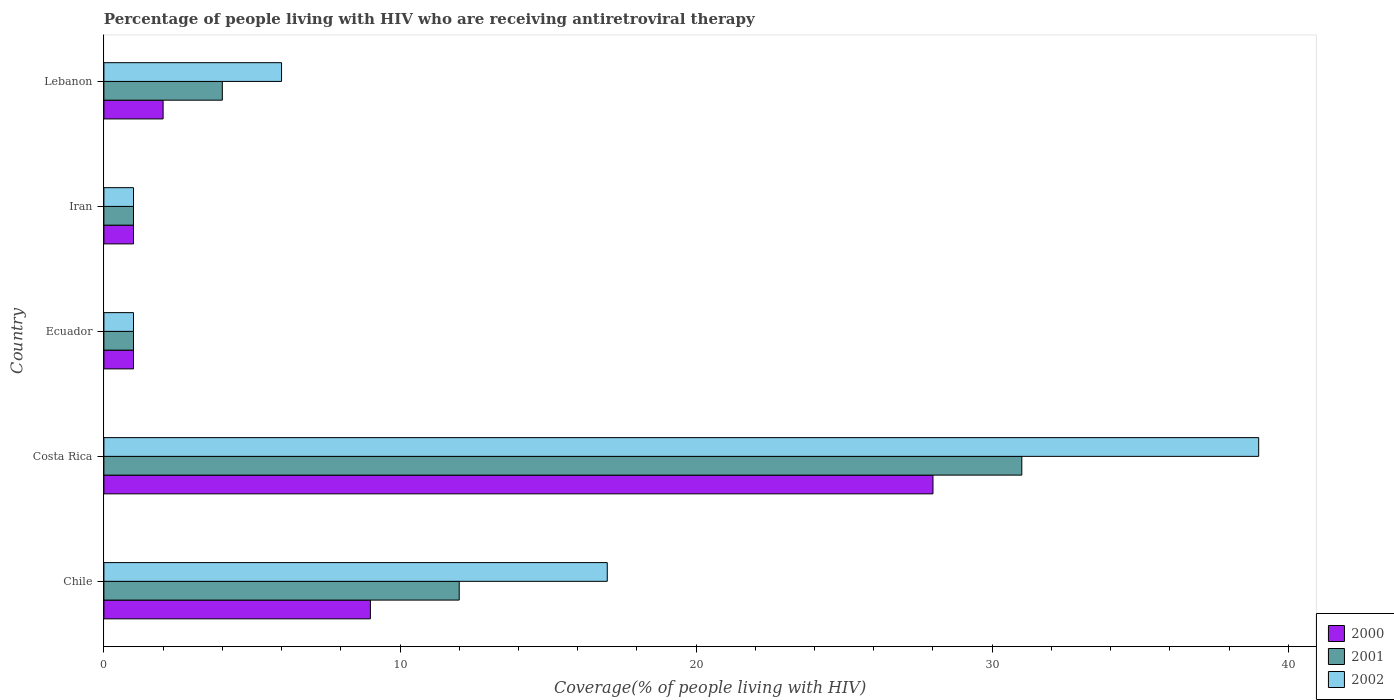How many different coloured bars are there?
Keep it short and to the point. 3. How many groups of bars are there?
Make the answer very short. 5. Are the number of bars per tick equal to the number of legend labels?
Make the answer very short. Yes. How many bars are there on the 1st tick from the bottom?
Ensure brevity in your answer.  3. What is the label of the 3rd group of bars from the top?
Your response must be concise. Ecuador. What is the percentage of the HIV infected people who are receiving antiretroviral therapy in 2002 in Chile?
Provide a succinct answer. 17. In which country was the percentage of the HIV infected people who are receiving antiretroviral therapy in 2000 maximum?
Keep it short and to the point. Costa Rica. In which country was the percentage of the HIV infected people who are receiving antiretroviral therapy in 2000 minimum?
Keep it short and to the point. Ecuador. What is the total percentage of the HIV infected people who are receiving antiretroviral therapy in 2002 in the graph?
Offer a terse response. 64. What is the difference between the percentage of the HIV infected people who are receiving antiretroviral therapy in 2001 in Chile and the percentage of the HIV infected people who are receiving antiretroviral therapy in 2002 in Lebanon?
Ensure brevity in your answer.  6. What is the difference between the percentage of the HIV infected people who are receiving antiretroviral therapy in 2001 and percentage of the HIV infected people who are receiving antiretroviral therapy in 2002 in Ecuador?
Keep it short and to the point. 0. Is the difference between the percentage of the HIV infected people who are receiving antiretroviral therapy in 2001 in Chile and Costa Rica greater than the difference between the percentage of the HIV infected people who are receiving antiretroviral therapy in 2002 in Chile and Costa Rica?
Offer a very short reply. Yes. What is the difference between the highest and the lowest percentage of the HIV infected people who are receiving antiretroviral therapy in 2001?
Your response must be concise. 30. Is the sum of the percentage of the HIV infected people who are receiving antiretroviral therapy in 2000 in Chile and Lebanon greater than the maximum percentage of the HIV infected people who are receiving antiretroviral therapy in 2002 across all countries?
Provide a short and direct response. No. Is it the case that in every country, the sum of the percentage of the HIV infected people who are receiving antiretroviral therapy in 2002 and percentage of the HIV infected people who are receiving antiretroviral therapy in 2000 is greater than the percentage of the HIV infected people who are receiving antiretroviral therapy in 2001?
Give a very brief answer. Yes. How many bars are there?
Keep it short and to the point. 15. What is the difference between two consecutive major ticks on the X-axis?
Offer a very short reply. 10. Are the values on the major ticks of X-axis written in scientific E-notation?
Ensure brevity in your answer.  No. Does the graph contain any zero values?
Offer a terse response. No. How many legend labels are there?
Provide a succinct answer. 3. How are the legend labels stacked?
Provide a succinct answer. Vertical. What is the title of the graph?
Keep it short and to the point. Percentage of people living with HIV who are receiving antiretroviral therapy. Does "2009" appear as one of the legend labels in the graph?
Ensure brevity in your answer.  No. What is the label or title of the X-axis?
Offer a terse response. Coverage(% of people living with HIV). What is the Coverage(% of people living with HIV) in 2002 in Chile?
Your answer should be compact. 17. What is the Coverage(% of people living with HIV) of 2001 in Costa Rica?
Your answer should be compact. 31. What is the Coverage(% of people living with HIV) in 2002 in Costa Rica?
Provide a succinct answer. 39. What is the Coverage(% of people living with HIV) in 2001 in Ecuador?
Keep it short and to the point. 1. What is the Coverage(% of people living with HIV) in 2002 in Iran?
Your response must be concise. 1. What is the Coverage(% of people living with HIV) of 2000 in Lebanon?
Give a very brief answer. 2. Across all countries, what is the maximum Coverage(% of people living with HIV) in 2001?
Your answer should be very brief. 31. Across all countries, what is the maximum Coverage(% of people living with HIV) of 2002?
Make the answer very short. 39. Across all countries, what is the minimum Coverage(% of people living with HIV) of 2000?
Make the answer very short. 1. Across all countries, what is the minimum Coverage(% of people living with HIV) of 2001?
Give a very brief answer. 1. What is the total Coverage(% of people living with HIV) in 2001 in the graph?
Your answer should be compact. 49. What is the total Coverage(% of people living with HIV) in 2002 in the graph?
Make the answer very short. 64. What is the difference between the Coverage(% of people living with HIV) in 2002 in Chile and that in Costa Rica?
Your answer should be very brief. -22. What is the difference between the Coverage(% of people living with HIV) in 2001 in Chile and that in Ecuador?
Provide a succinct answer. 11. What is the difference between the Coverage(% of people living with HIV) of 2002 in Chile and that in Ecuador?
Your response must be concise. 16. What is the difference between the Coverage(% of people living with HIV) of 2000 in Chile and that in Iran?
Give a very brief answer. 8. What is the difference between the Coverage(% of people living with HIV) of 2002 in Chile and that in Iran?
Offer a terse response. 16. What is the difference between the Coverage(% of people living with HIV) of 2000 in Chile and that in Lebanon?
Give a very brief answer. 7. What is the difference between the Coverage(% of people living with HIV) in 2001 in Costa Rica and that in Ecuador?
Make the answer very short. 30. What is the difference between the Coverage(% of people living with HIV) of 2000 in Costa Rica and that in Iran?
Give a very brief answer. 27. What is the difference between the Coverage(% of people living with HIV) of 2002 in Costa Rica and that in Iran?
Ensure brevity in your answer.  38. What is the difference between the Coverage(% of people living with HIV) in 2001 in Costa Rica and that in Lebanon?
Offer a very short reply. 27. What is the difference between the Coverage(% of people living with HIV) in 2001 in Ecuador and that in Iran?
Offer a very short reply. 0. What is the difference between the Coverage(% of people living with HIV) of 2000 in Iran and that in Lebanon?
Your answer should be very brief. -1. What is the difference between the Coverage(% of people living with HIV) in 2000 in Chile and the Coverage(% of people living with HIV) in 2001 in Ecuador?
Provide a short and direct response. 8. What is the difference between the Coverage(% of people living with HIV) of 2000 in Chile and the Coverage(% of people living with HIV) of 2002 in Iran?
Your response must be concise. 8. What is the difference between the Coverage(% of people living with HIV) in 2001 in Chile and the Coverage(% of people living with HIV) in 2002 in Iran?
Your response must be concise. 11. What is the difference between the Coverage(% of people living with HIV) of 2000 in Chile and the Coverage(% of people living with HIV) of 2001 in Lebanon?
Ensure brevity in your answer.  5. What is the difference between the Coverage(% of people living with HIV) of 2000 in Chile and the Coverage(% of people living with HIV) of 2002 in Lebanon?
Make the answer very short. 3. What is the difference between the Coverage(% of people living with HIV) of 2001 in Chile and the Coverage(% of people living with HIV) of 2002 in Lebanon?
Offer a terse response. 6. What is the difference between the Coverage(% of people living with HIV) of 2000 in Costa Rica and the Coverage(% of people living with HIV) of 2001 in Ecuador?
Your answer should be very brief. 27. What is the difference between the Coverage(% of people living with HIV) in 2000 in Costa Rica and the Coverage(% of people living with HIV) in 2002 in Ecuador?
Your response must be concise. 27. What is the difference between the Coverage(% of people living with HIV) in 2000 in Costa Rica and the Coverage(% of people living with HIV) in 2002 in Iran?
Your answer should be compact. 27. What is the difference between the Coverage(% of people living with HIV) in 2001 in Costa Rica and the Coverage(% of people living with HIV) in 2002 in Iran?
Give a very brief answer. 30. What is the difference between the Coverage(% of people living with HIV) in 2000 in Costa Rica and the Coverage(% of people living with HIV) in 2002 in Lebanon?
Provide a succinct answer. 22. What is the difference between the Coverage(% of people living with HIV) of 2001 in Costa Rica and the Coverage(% of people living with HIV) of 2002 in Lebanon?
Keep it short and to the point. 25. What is the difference between the Coverage(% of people living with HIV) of 2000 in Ecuador and the Coverage(% of people living with HIV) of 2001 in Iran?
Offer a terse response. 0. What is the difference between the Coverage(% of people living with HIV) of 2000 in Ecuador and the Coverage(% of people living with HIV) of 2002 in Iran?
Provide a short and direct response. 0. What is the difference between the Coverage(% of people living with HIV) in 2001 in Ecuador and the Coverage(% of people living with HIV) in 2002 in Lebanon?
Your response must be concise. -5. What is the difference between the Coverage(% of people living with HIV) of 2000 in Iran and the Coverage(% of people living with HIV) of 2001 in Lebanon?
Your answer should be very brief. -3. What is the average Coverage(% of people living with HIV) in 2001 per country?
Make the answer very short. 9.8. What is the difference between the Coverage(% of people living with HIV) of 2000 and Coverage(% of people living with HIV) of 2001 in Chile?
Make the answer very short. -3. What is the difference between the Coverage(% of people living with HIV) of 2000 and Coverage(% of people living with HIV) of 2002 in Chile?
Give a very brief answer. -8. What is the difference between the Coverage(% of people living with HIV) in 2000 and Coverage(% of people living with HIV) in 2002 in Costa Rica?
Offer a terse response. -11. What is the difference between the Coverage(% of people living with HIV) of 2001 and Coverage(% of people living with HIV) of 2002 in Costa Rica?
Offer a terse response. -8. What is the difference between the Coverage(% of people living with HIV) of 2000 and Coverage(% of people living with HIV) of 2001 in Ecuador?
Provide a succinct answer. 0. What is the difference between the Coverage(% of people living with HIV) in 2000 and Coverage(% of people living with HIV) in 2002 in Ecuador?
Give a very brief answer. 0. What is the difference between the Coverage(% of people living with HIV) in 2000 and Coverage(% of people living with HIV) in 2002 in Iran?
Provide a short and direct response. 0. What is the difference between the Coverage(% of people living with HIV) in 2001 and Coverage(% of people living with HIV) in 2002 in Iran?
Ensure brevity in your answer.  0. What is the ratio of the Coverage(% of people living with HIV) in 2000 in Chile to that in Costa Rica?
Provide a short and direct response. 0.32. What is the ratio of the Coverage(% of people living with HIV) in 2001 in Chile to that in Costa Rica?
Your response must be concise. 0.39. What is the ratio of the Coverage(% of people living with HIV) of 2002 in Chile to that in Costa Rica?
Your response must be concise. 0.44. What is the ratio of the Coverage(% of people living with HIV) of 2001 in Chile to that in Ecuador?
Give a very brief answer. 12. What is the ratio of the Coverage(% of people living with HIV) of 2002 in Chile to that in Ecuador?
Your answer should be very brief. 17. What is the ratio of the Coverage(% of people living with HIV) in 2000 in Chile to that in Iran?
Offer a very short reply. 9. What is the ratio of the Coverage(% of people living with HIV) of 2002 in Chile to that in Lebanon?
Keep it short and to the point. 2.83. What is the ratio of the Coverage(% of people living with HIV) in 2001 in Costa Rica to that in Ecuador?
Ensure brevity in your answer.  31. What is the ratio of the Coverage(% of people living with HIV) of 2002 in Costa Rica to that in Ecuador?
Ensure brevity in your answer.  39. What is the ratio of the Coverage(% of people living with HIV) in 2000 in Costa Rica to that in Iran?
Offer a very short reply. 28. What is the ratio of the Coverage(% of people living with HIV) in 2002 in Costa Rica to that in Iran?
Offer a very short reply. 39. What is the ratio of the Coverage(% of people living with HIV) of 2001 in Costa Rica to that in Lebanon?
Make the answer very short. 7.75. What is the ratio of the Coverage(% of people living with HIV) of 2002 in Costa Rica to that in Lebanon?
Your answer should be compact. 6.5. What is the ratio of the Coverage(% of people living with HIV) in 2000 in Ecuador to that in Iran?
Your answer should be compact. 1. What is the ratio of the Coverage(% of people living with HIV) of 2000 in Iran to that in Lebanon?
Offer a very short reply. 0.5. What is the ratio of the Coverage(% of people living with HIV) of 2001 in Iran to that in Lebanon?
Give a very brief answer. 0.25. What is the ratio of the Coverage(% of people living with HIV) in 2002 in Iran to that in Lebanon?
Provide a short and direct response. 0.17. What is the difference between the highest and the lowest Coverage(% of people living with HIV) in 2001?
Your response must be concise. 30. What is the difference between the highest and the lowest Coverage(% of people living with HIV) of 2002?
Keep it short and to the point. 38. 